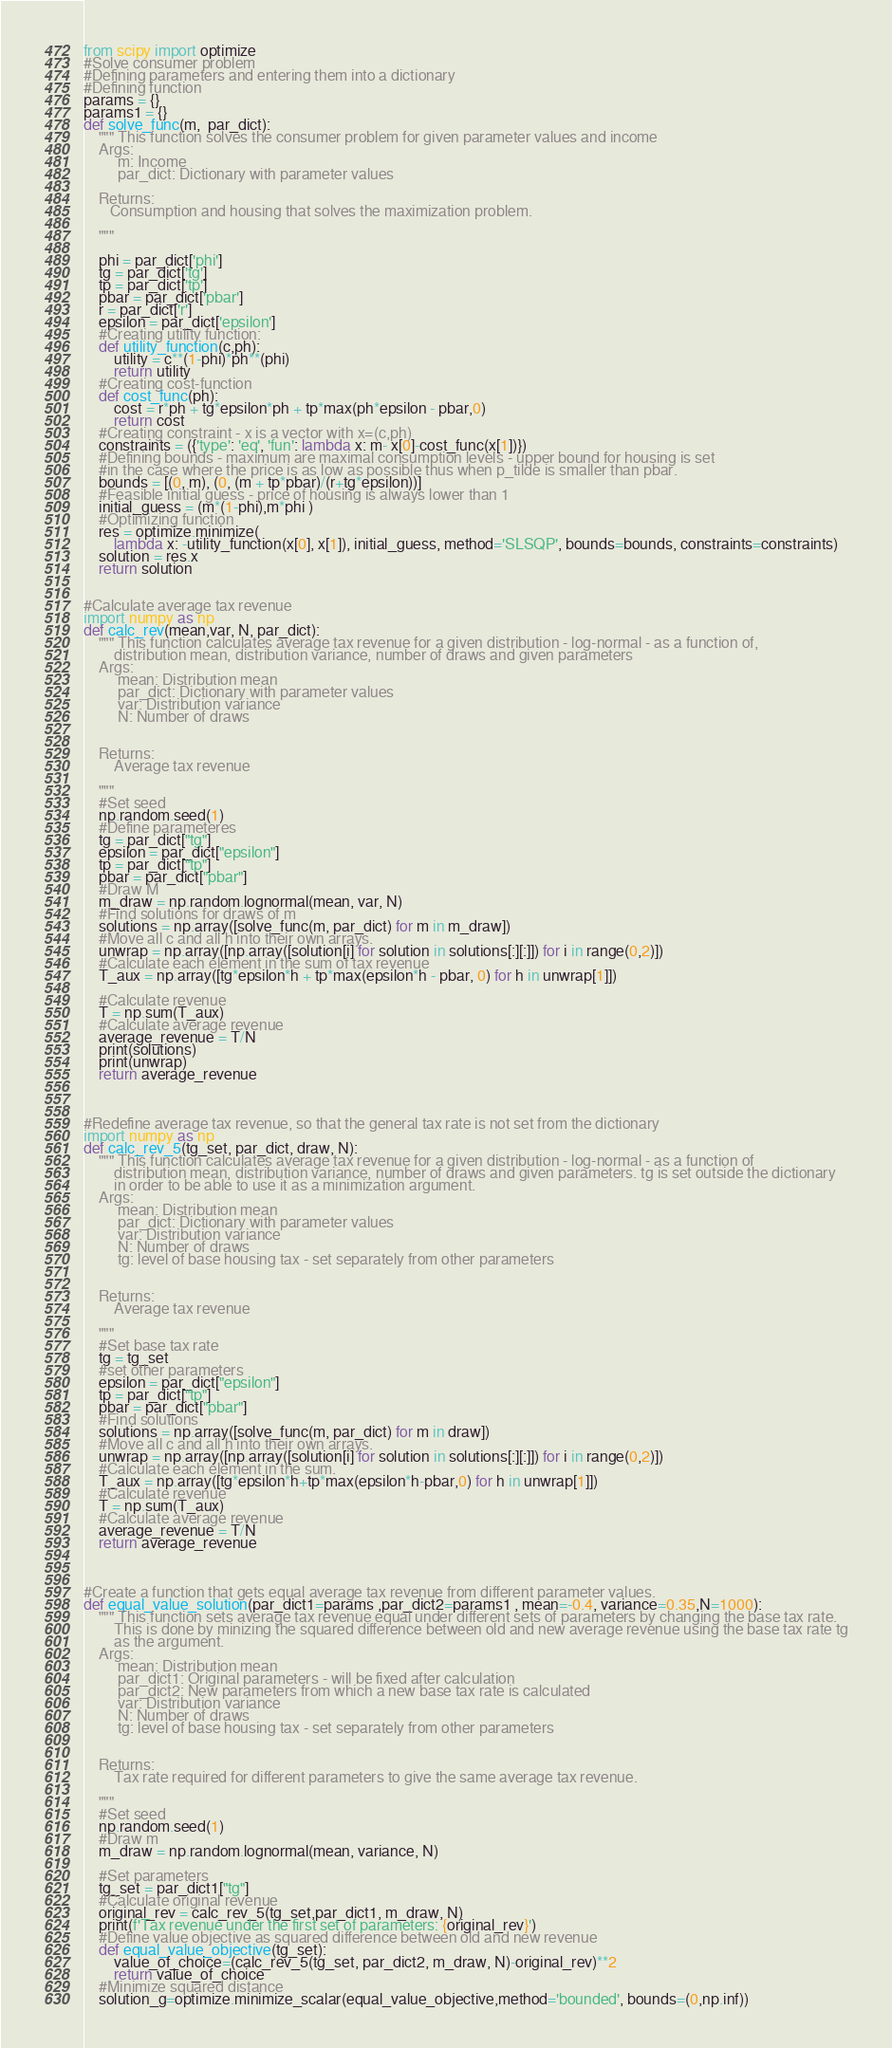<code> <loc_0><loc_0><loc_500><loc_500><_Python_>from scipy import optimize
#Solve consumer problem
#Defining parameters and entering them into a dictionary
#Defining function
params = {}
params1 = {}
def solve_func(m,  par_dict):
    """ This function solves the consumer problem for given parameter values and income
    Args:
         m: Income
         par_dict: Dictionary with parameter values

    Returns:
       Consumption and housing that solves the maximization problem.

    """

    phi = par_dict['phi']
    tg = par_dict['tg']
    tp = par_dict['tp']
    pbar = par_dict['pbar']
    r = par_dict['r']
    epsilon = par_dict['epsilon']
    #Creating utility function:
    def utility_function(c,ph):
        utility = c**(1-phi)*ph**(phi)
        return utility
    #Creating cost-function 
    def cost_func(ph):
        cost = r*ph + tg*epsilon*ph + tp*max(ph*epsilon - pbar,0)
        return cost
    #Creating constraint - x is a vector with x=(c,ph)
    constraints = ({'type': 'eq', 'fun': lambda x: m- x[0]-cost_func(x[1])})
    #Defining bounds - maximum are maximal consumption levels - upper bound for housing is set 
    #in the case where the price is as low as possible thus when p_tilde is smaller than pbar. 
    bounds = [(0, m), (0, (m + tp*pbar)/(r+tg*epsilon))]
    #Feasible initial guess - price of housing is always lower than 1
    initial_guess = (m*(1-phi),m*phi )
    #Optimizing function
    res = optimize.minimize(
        lambda x: -utility_function(x[0], x[1]), initial_guess, method='SLSQP', bounds=bounds, constraints=constraints)
    solution = res.x
    return solution


#Calculate average tax revenue
import numpy as np
def calc_rev(mean,var, N, par_dict):
    """ This function calculates average tax revenue for a given distribution - log-normal - as a function of,
        distribution mean, distribution variance, number of draws and given parameters
    Args:
         mean: Distribution mean
         par_dict: Dictionary with parameter values
         var: Distribution variance
         N: Number of draws


    Returns:
        Average tax revenue

    """
    #Set seed
    np.random.seed(1)
    #Define parameteres
    tg = par_dict["tg"]
    epsilon = par_dict["epsilon"]
    tp = par_dict["tp"]
    pbar = par_dict["pbar"]
    #Draw M
    m_draw = np.random.lognormal(mean, var, N)
    #Find solutions for draws of m
    solutions = np.array([solve_func(m, par_dict) for m in m_draw])
    #Move all c and all h into their own arrays.
    unwrap = np.array([np.array([solution[i] for solution in solutions[:][:]]) for i in range(0,2)])
    #Calculate each element in the sum of tax revenue
    T_aux = np.array([tg*epsilon*h + tp*max(epsilon*h - pbar, 0) for h in unwrap[1]])

    #Calculate revenue
    T = np.sum(T_aux)
    #Calculate average revenue
    average_revenue = T/N
    print(solutions)
    print(unwrap)
    return average_revenue



#Redefine average tax revenue, so that the general tax rate is not set from the dictionary
import numpy as np
def calc_rev_5(tg_set, par_dict, draw, N):
    """ This function calculates average tax revenue for a given distribution - log-normal - as a function of
        distribution mean, distribution variance, number of draws and given parameters. tg is set outside the dictionary
        in order to be able to use it as a minimization argument. 
    Args:
         mean: Distribution mean
         par_dict: Dictionary with parameter values
         var: Distribution variance
         N: Number of draws
         tg: level of base housing tax - set separately from other parameters


    Returns:
        Average tax revenue

    """
    #Set base tax rate
    tg = tg_set
    #set other parameters
    epsilon = par_dict["epsilon"]
    tp = par_dict["tp"]
    pbar = par_dict["pbar"]
    #Find solutions
    solutions = np.array([solve_func(m, par_dict) for m in draw])
    #Move all c and all h into their own arrays.
    unwrap = np.array([np.array([solution[i] for solution in solutions[:][:]]) for i in range(0,2)])
    #Calculate each element in the sum. 
    T_aux = np.array([tg*epsilon*h+tp*max(epsilon*h-pbar,0) for h in unwrap[1]])
    #Calculate revenue
    T = np.sum(T_aux)
    #Calculate average revenue
    average_revenue = T/N
    return average_revenue



#Create a function that gets equal average tax revenue from different parameter values. 
def equal_value_solution(par_dict1=params ,par_dict2=params1 , mean=-0.4, variance=0.35,N=1000):
    """ This function sets average tax revenue equal under different sets of parameters by changing the base tax rate.
        This is done by minizing the squared difference between old and new average revenue using the base tax rate tg
        as the argument. 
    Args:
         mean: Distribution mean
         par_dict1: Original parameters - will be fixed after calculation
         par_dict2: New parameters from which a new base tax rate is calculated
         var: Distribution variance
         N: Number of draws
         tg: level of base housing tax - set separately from other parameters


    Returns:
        Tax rate required for different parameters to give the same average tax revenue.

    """
    #Set seed
    np.random.seed(1)
    #Draw m
    m_draw = np.random.lognormal(mean, variance, N)

    #Set parameters
    tg_set = par_dict1["tg"]
    #Calculate original revenue
    original_rev = calc_rev_5(tg_set,par_dict1, m_draw, N)
    print(f'Tax revenue under the first set of parameters: {original_rev}')
    #Define value objective as squared difference between old and new revenue
    def equal_value_objective(tg_set):
        value_of_choice=(calc_rev_5(tg_set, par_dict2, m_draw, N)-original_rev)**2
        return value_of_choice
    #Minimize squared distance        
    solution_g=optimize.minimize_scalar(equal_value_objective,method='bounded', bounds=(0,np.inf))</code> 